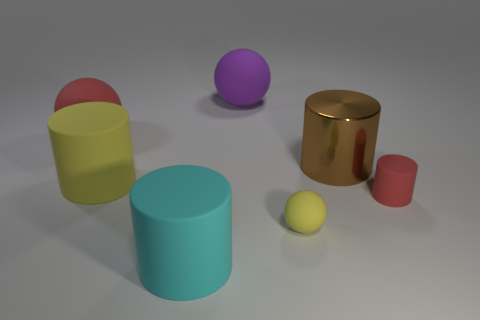Are there fewer purple objects than objects? Yes, there is only one purple object visible in the image, which means there are fewer purple objects compared to the total number of objects present. 